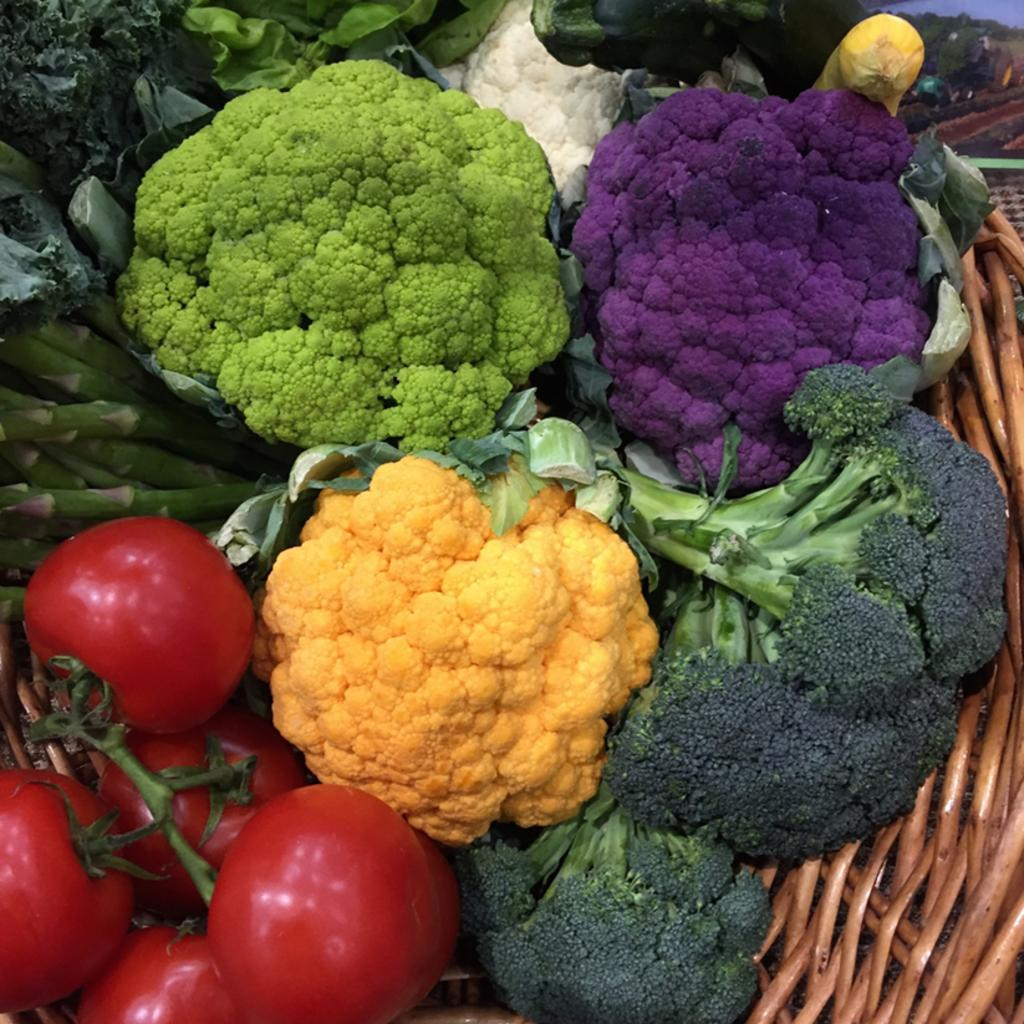What types of vegetables are in the basket in the image? There are cauliflowers, broccoli, tomatoes, and asparagus in the basket. Are there any other vegetables in the basket besides the ones mentioned? Yes, there are other unspecified vegetables in the basket. Can you describe the color of the tomatoes in the basket? The provided facts do not mention the color of the tomatoes, so it cannot be determined from the image. Can you tell me how the giraffe is feeling in the image? There is no giraffe present in the image; it features a basket of vegetables. What is the vegetable that the giraffe is afraid of in the image? There is no giraffe or fear of vegetables present in the image. 